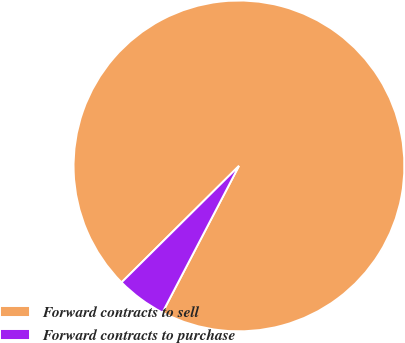Convert chart. <chart><loc_0><loc_0><loc_500><loc_500><pie_chart><fcel>Forward contracts to sell<fcel>Forward contracts to purchase<nl><fcel>95.09%<fcel>4.91%<nl></chart> 